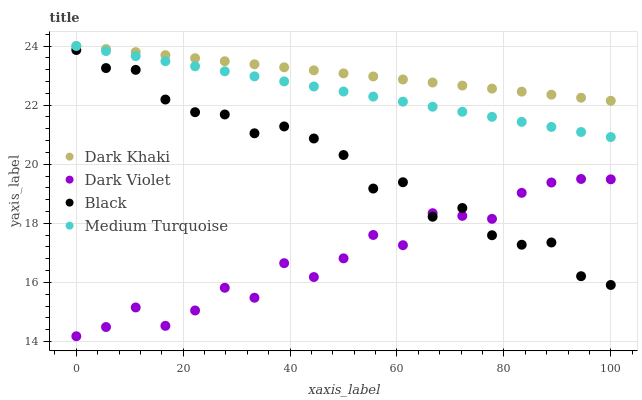Does Dark Violet have the minimum area under the curve?
Answer yes or no. Yes. Does Dark Khaki have the maximum area under the curve?
Answer yes or no. Yes. Does Black have the minimum area under the curve?
Answer yes or no. No. Does Black have the maximum area under the curve?
Answer yes or no. No. Is Dark Khaki the smoothest?
Answer yes or no. Yes. Is Dark Violet the roughest?
Answer yes or no. Yes. Is Black the smoothest?
Answer yes or no. No. Is Black the roughest?
Answer yes or no. No. Does Dark Violet have the lowest value?
Answer yes or no. Yes. Does Black have the lowest value?
Answer yes or no. No. Does Medium Turquoise have the highest value?
Answer yes or no. Yes. Does Black have the highest value?
Answer yes or no. No. Is Dark Violet less than Medium Turquoise?
Answer yes or no. Yes. Is Medium Turquoise greater than Black?
Answer yes or no. Yes. Does Medium Turquoise intersect Dark Khaki?
Answer yes or no. Yes. Is Medium Turquoise less than Dark Khaki?
Answer yes or no. No. Is Medium Turquoise greater than Dark Khaki?
Answer yes or no. No. Does Dark Violet intersect Medium Turquoise?
Answer yes or no. No. 